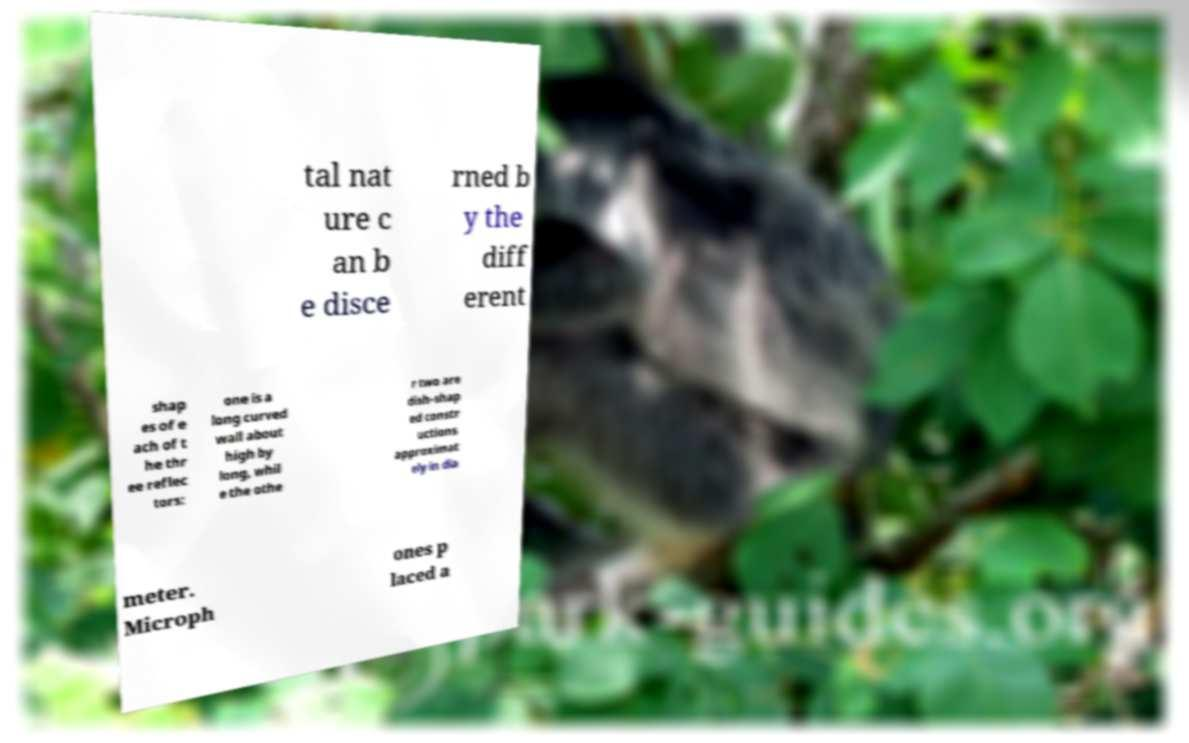For documentation purposes, I need the text within this image transcribed. Could you provide that? tal nat ure c an b e disce rned b y the diff erent shap es of e ach of t he thr ee reflec tors: one is a long curved wall about high by long, whil e the othe r two are dish-shap ed constr uctions approximat ely in dia meter. Microph ones p laced a 